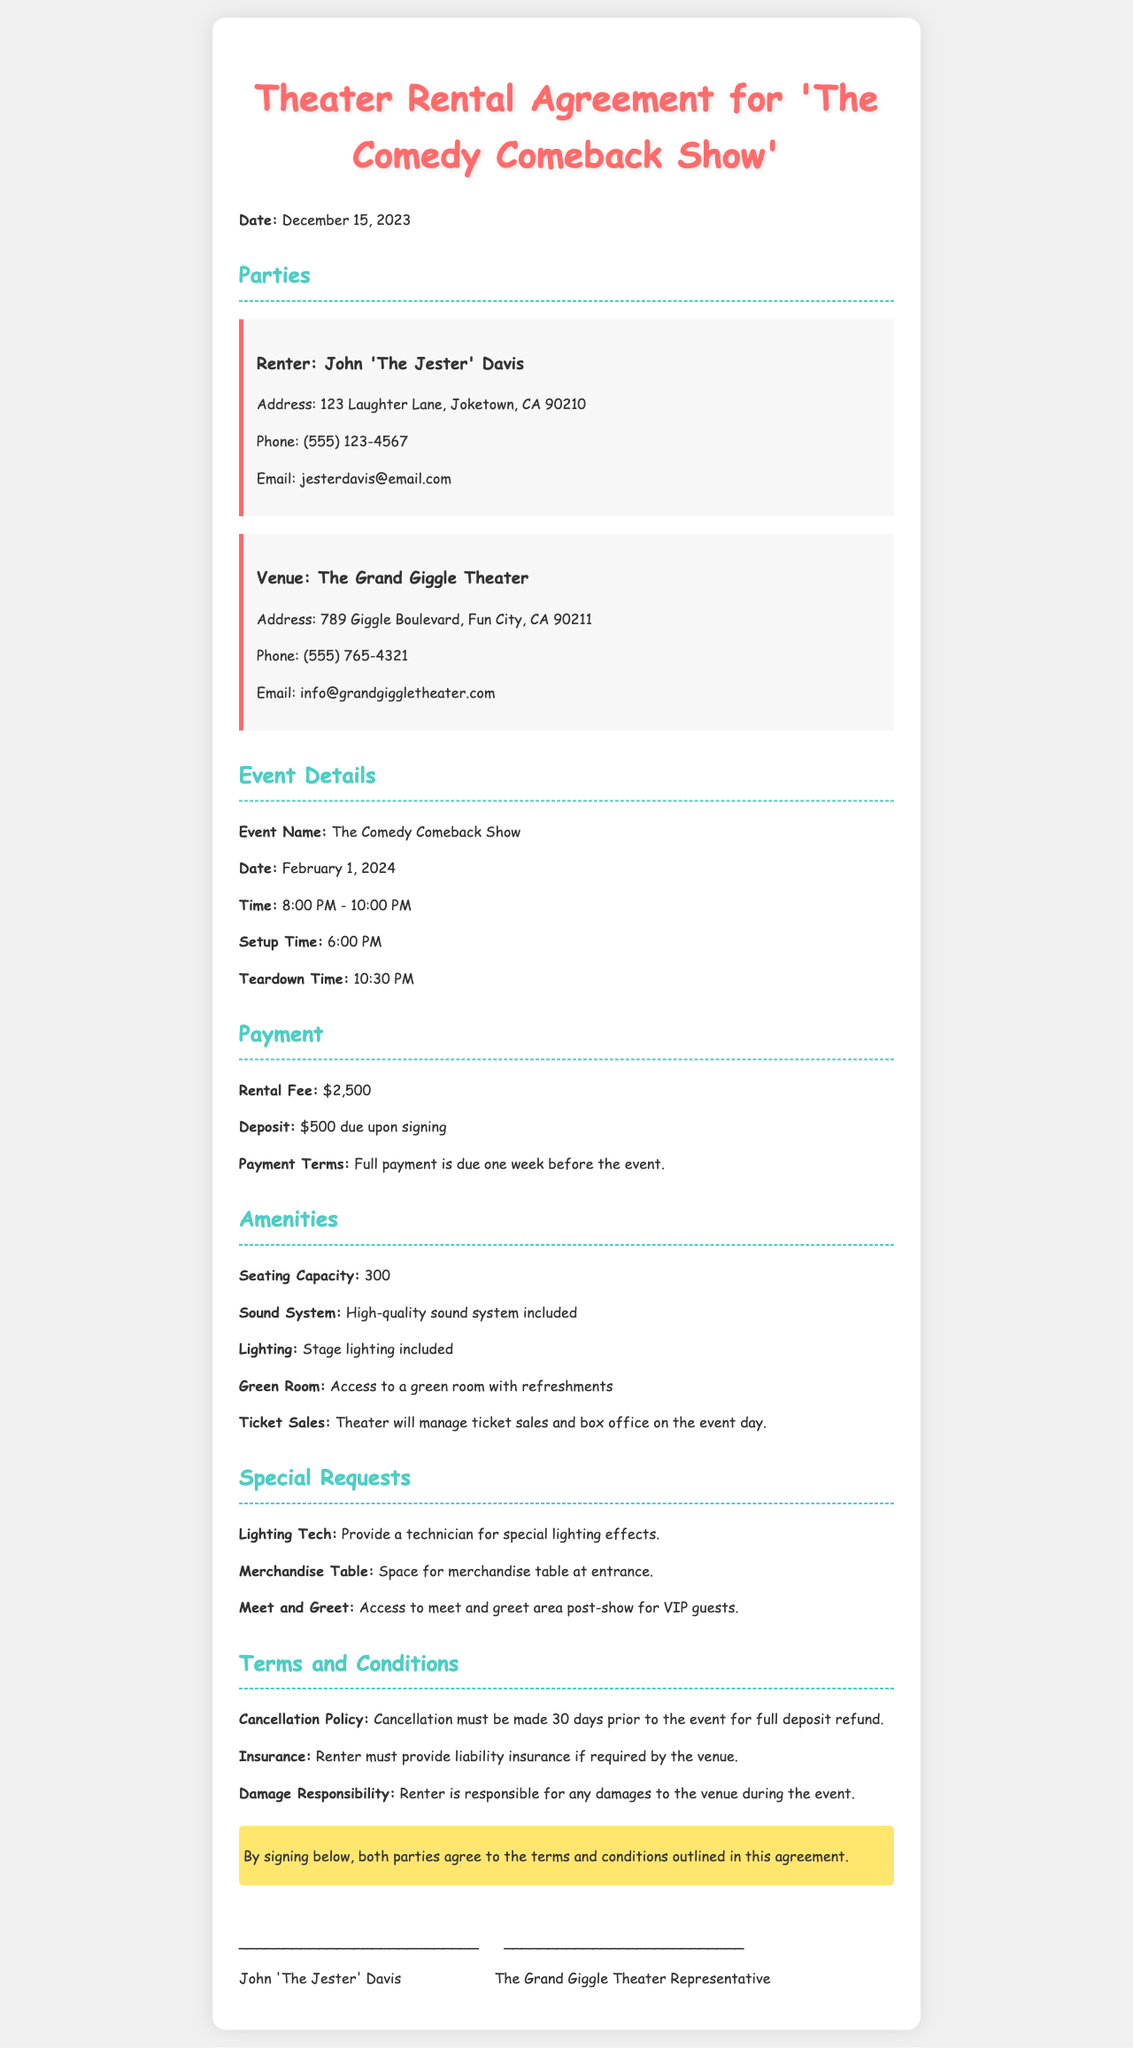What is the date of the event? The date of the event is explicitly stated in the document as February 1, 2024.
Answer: February 1, 2024 What is the rental fee for the venue? The rental fee is mentioned in the payment section of the document as $2,500.
Answer: $2,500 Who is the renter listed in the agreement? The document names the renter as John 'The Jester' Davis, which is specified in the parties section.
Answer: John 'The Jester' Davis What time is the event scheduled to start? The event start time is provided in the event details section, listed as 8:00 PM.
Answer: 8:00 PM How long do we have to cancel for a full deposit refund? The cancellation policy states that cancellation must be made 30 days prior to the event for a full deposit refund, requiring reasoning through that section.
Answer: 30 days How many people can the theater accommodate? The seating capacity of the theater is mentioned in the amenities section as 300.
Answer: 300 What is included in the amenities regarding sound? The document states that a high-quality sound system is included, referring to the amenities section.
Answer: High-quality sound system What must the renter provide if required by the venue? The terms section indicates that the renter must provide liability insurance if required by the venue.
Answer: Liability insurance What special request involves merchandise? The document mentions a space for a merchandise table at the entrance in the special requests section.
Answer: Merchandise table 